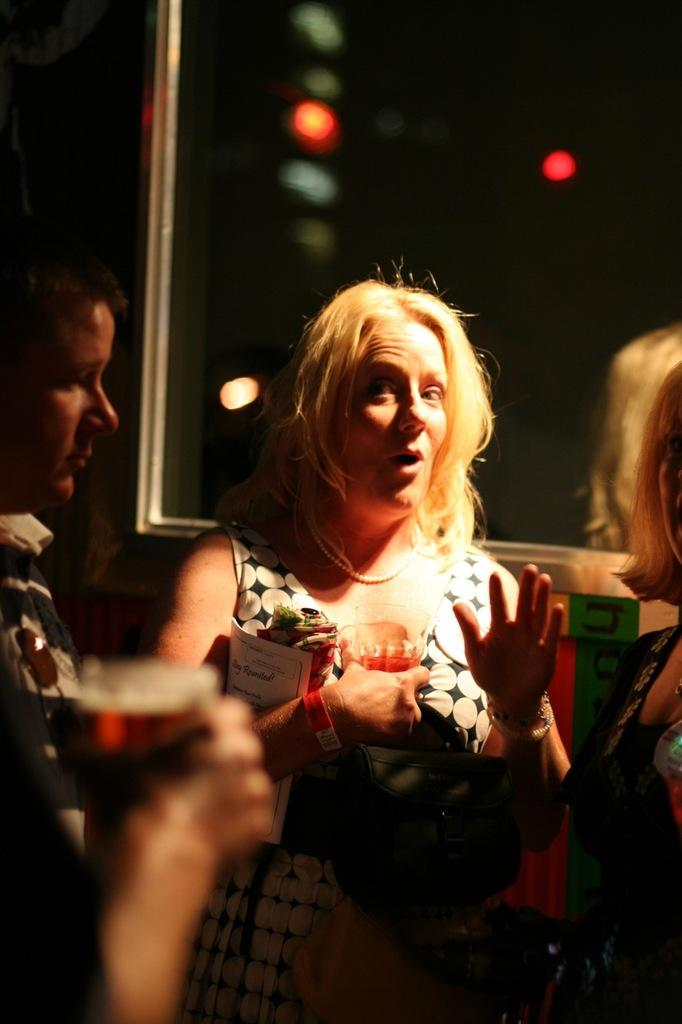What is happening in the image? There are people standing in the image. Can you describe the background of the image? The background of the image is blurred. What type of spoon is being used to amplify the sound in the image? There is no spoon present in the image, and the image does not depict any sound amplification. 